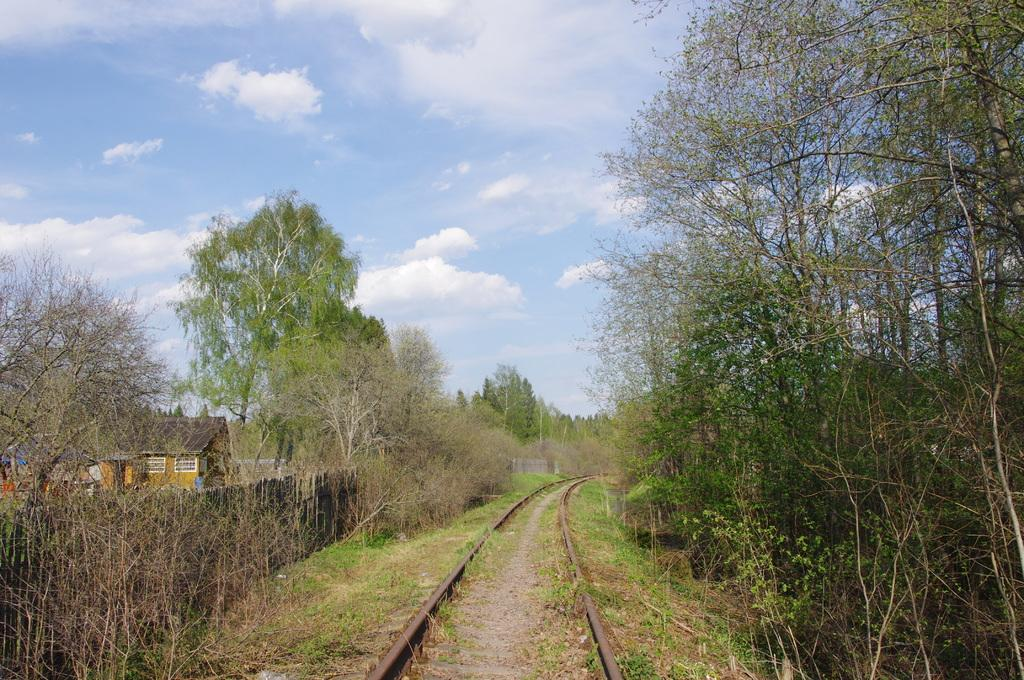What type of transportation infrastructure is present in the image? There is a railway track in the image. What type of vegetation can be seen in the image? Grass, plants, and trees are visible in the image. What type of barrier is present in the image? There is a wooden fence in the image. What type of building is present in the image? There is a house in the image. What part of the natural environment is visible in the background of the image? The sky is visible in the background of the image. What type of musical instrument is being played in the image? There is no musical instrument present in the image. What type of hair grooming tool is visible in the image? There is no comb present in the image. 